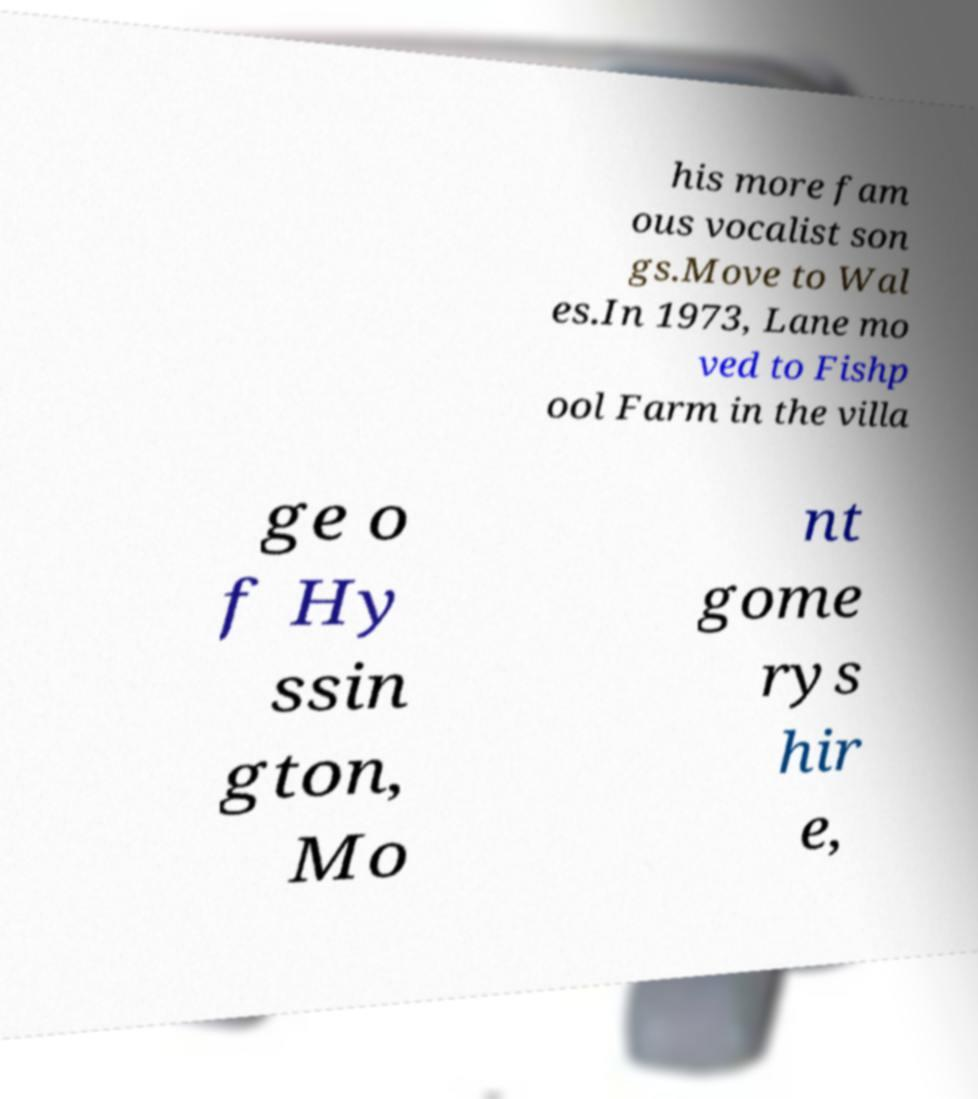Could you extract and type out the text from this image? his more fam ous vocalist son gs.Move to Wal es.In 1973, Lane mo ved to Fishp ool Farm in the villa ge o f Hy ssin gton, Mo nt gome rys hir e, 